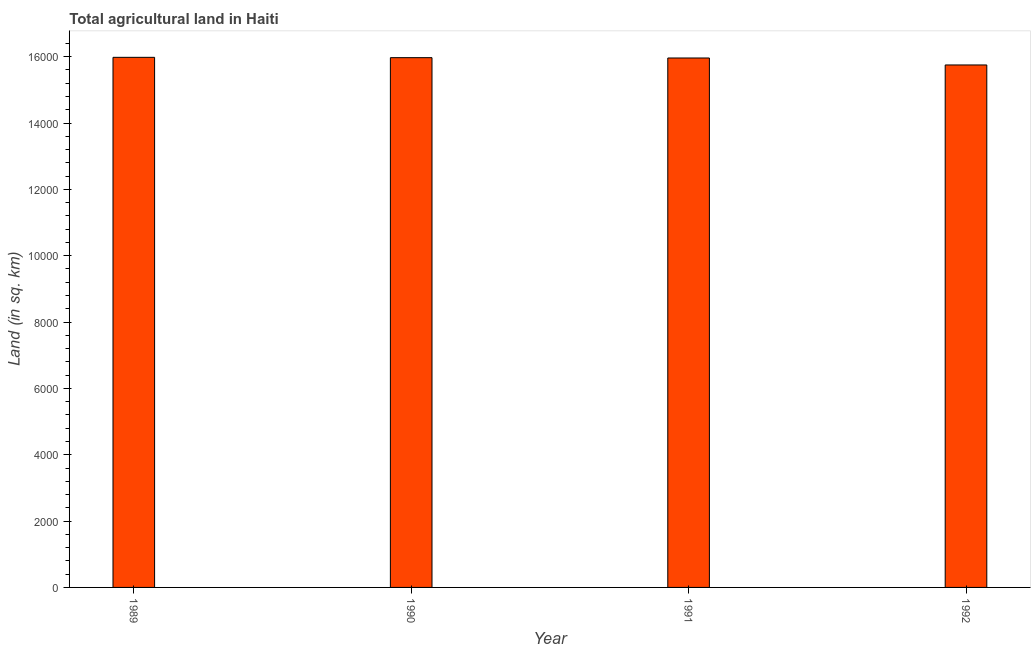What is the title of the graph?
Give a very brief answer. Total agricultural land in Haiti. What is the label or title of the Y-axis?
Make the answer very short. Land (in sq. km). What is the agricultural land in 1990?
Offer a very short reply. 1.60e+04. Across all years, what is the maximum agricultural land?
Offer a very short reply. 1.60e+04. Across all years, what is the minimum agricultural land?
Your answer should be compact. 1.58e+04. What is the sum of the agricultural land?
Keep it short and to the point. 6.37e+04. What is the difference between the agricultural land in 1991 and 1992?
Make the answer very short. 210. What is the average agricultural land per year?
Offer a very short reply. 1.59e+04. What is the median agricultural land?
Provide a short and direct response. 1.60e+04. In how many years, is the agricultural land greater than 4400 sq. km?
Your answer should be compact. 4. Do a majority of the years between 1991 and 1992 (inclusive) have agricultural land greater than 1600 sq. km?
Your response must be concise. Yes. What is the difference between the highest and the second highest agricultural land?
Provide a short and direct response. 10. What is the difference between the highest and the lowest agricultural land?
Your response must be concise. 230. In how many years, is the agricultural land greater than the average agricultural land taken over all years?
Your answer should be very brief. 3. How many bars are there?
Ensure brevity in your answer.  4. How many years are there in the graph?
Offer a terse response. 4. What is the Land (in sq. km) in 1989?
Offer a very short reply. 1.60e+04. What is the Land (in sq. km) of 1990?
Provide a short and direct response. 1.60e+04. What is the Land (in sq. km) of 1991?
Ensure brevity in your answer.  1.60e+04. What is the Land (in sq. km) of 1992?
Offer a very short reply. 1.58e+04. What is the difference between the Land (in sq. km) in 1989 and 1990?
Keep it short and to the point. 10. What is the difference between the Land (in sq. km) in 1989 and 1991?
Provide a succinct answer. 20. What is the difference between the Land (in sq. km) in 1989 and 1992?
Your answer should be very brief. 230. What is the difference between the Land (in sq. km) in 1990 and 1991?
Provide a short and direct response. 10. What is the difference between the Land (in sq. km) in 1990 and 1992?
Your answer should be very brief. 220. What is the difference between the Land (in sq. km) in 1991 and 1992?
Give a very brief answer. 210. What is the ratio of the Land (in sq. km) in 1989 to that in 1990?
Give a very brief answer. 1. What is the ratio of the Land (in sq. km) in 1990 to that in 1991?
Provide a short and direct response. 1. 